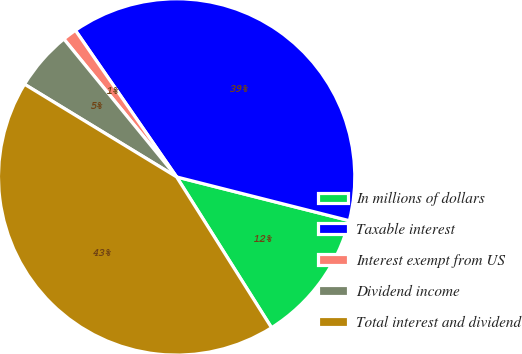Convert chart to OTSL. <chart><loc_0><loc_0><loc_500><loc_500><pie_chart><fcel>In millions of dollars<fcel>Taxable interest<fcel>Interest exempt from US<fcel>Dividend income<fcel>Total interest and dividend<nl><fcel>12.11%<fcel>38.56%<fcel>1.29%<fcel>5.38%<fcel>42.65%<nl></chart> 